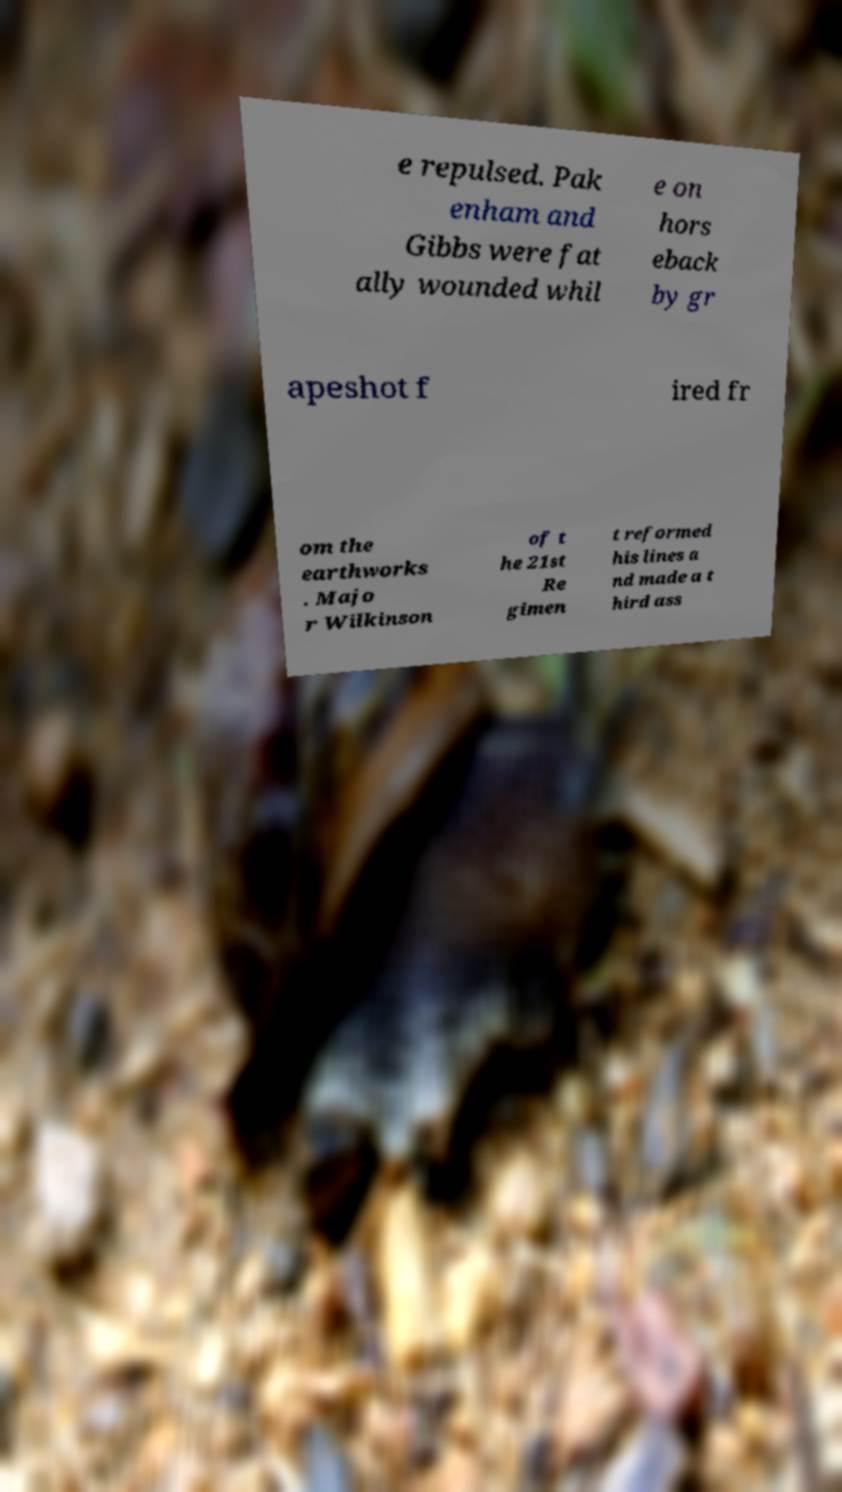Can you read and provide the text displayed in the image?This photo seems to have some interesting text. Can you extract and type it out for me? e repulsed. Pak enham and Gibbs were fat ally wounded whil e on hors eback by gr apeshot f ired fr om the earthworks . Majo r Wilkinson of t he 21st Re gimen t reformed his lines a nd made a t hird ass 